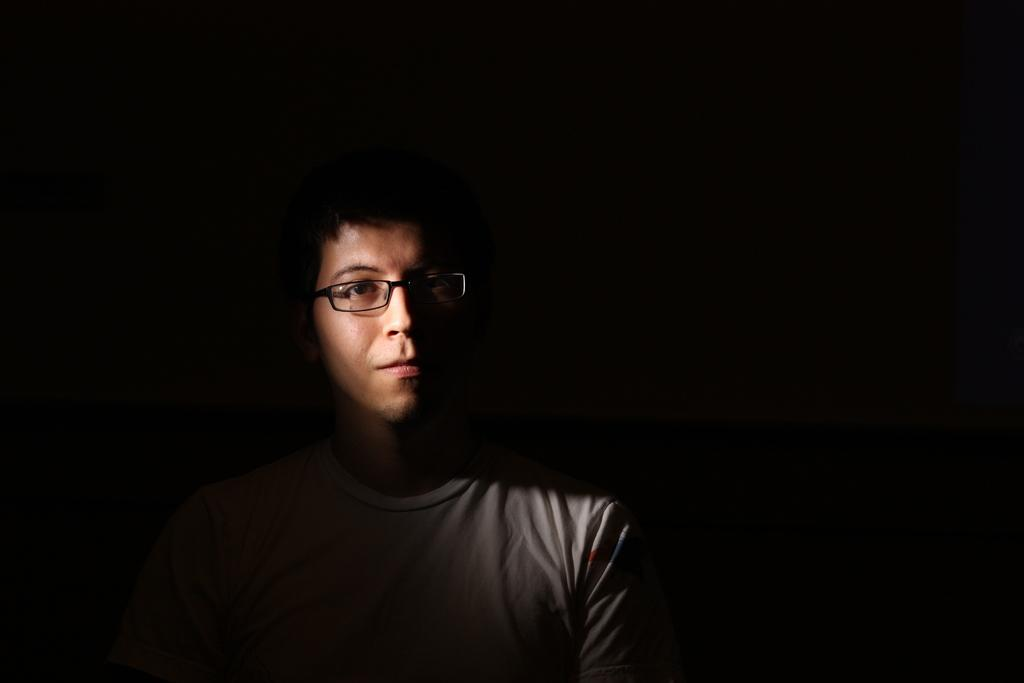What is the main subject in the foreground of the picture? There is a man in the foreground of the picture. What is the man wearing on his upper body? The man is wearing a grey T-shirt. Are there any accessories visible on the man? Yes, the man is wearing spectacles. What can be observed about the background of the image? The background of the image is dark. What color is the nail on the man's finger in the image? There is no nail visible on the man's finger in the image. Can you see any wings on the man in the image? There are no wings visible on the man in the image. 